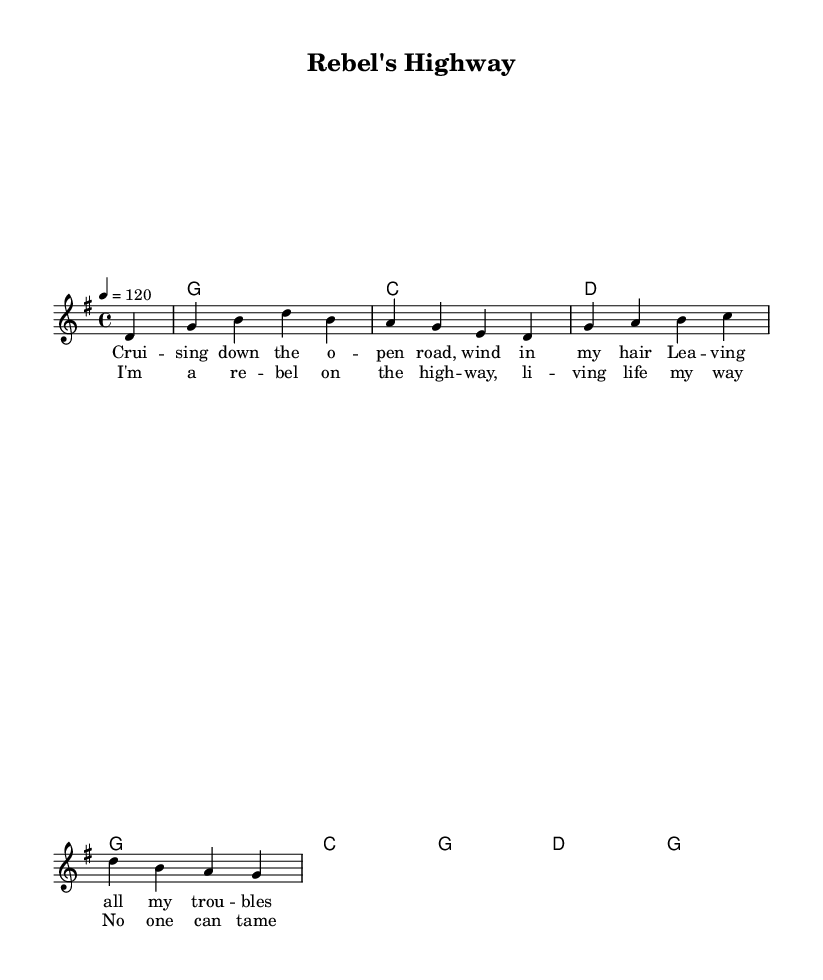What is the key signature of this music? The key signature is G major, which has one sharp (F#). You can determine this by looking at the first part of the global variable section that sets the key to \key g \major.
Answer: G major What is the time signature of the piece? The time signature is 4/4, which indicates that there are four beats in a measure and the quarter note receives one beat. This can be identified in the global variable section by the \time command that specifies 4/4.
Answer: 4/4 What is the tempo marking for the song? The tempo marking is 120 beats per minute, which indicates the speed at which the music should be played. This is found in the global variable section where \tempo 4 = 120 is defined.
Answer: 120 How is the chord progression structured in the harmonies? The chord progression alternates between G, C, and D chords, each sustained for one measure (whole note). This can be observed in the \chordmode section where the chords are listed. The order is G, C, D, G, C, G, D, G.
Answer: G, C, D What theme is expressed in the lyrics of the chorus? The theme of the chorus expresses independence and a free spirit, encapsulated in the lines about being a rebel and living life on one's own terms. This is evident from the lyrics which mention "I'm a rebel on the highway" and "No one can tame this wild heart."
Answer: Independence What style of music does this piece represent? This piece represents country rock, particularly the classic outlaw country rock style that was prevalent in the 70s. You can identify it by the lyrical themes of rebellion and the musical structure typical of country rock anthems.
Answer: Country rock 